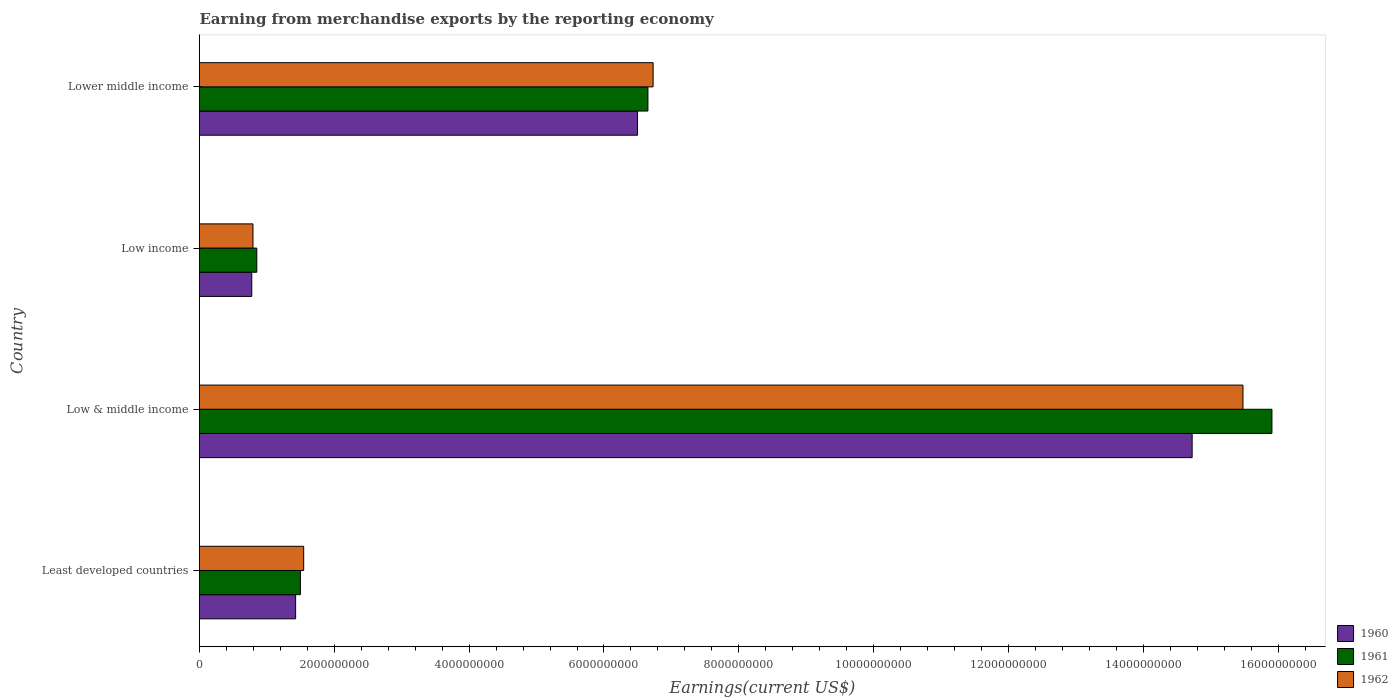How many different coloured bars are there?
Provide a short and direct response. 3. How many groups of bars are there?
Your response must be concise. 4. Are the number of bars on each tick of the Y-axis equal?
Provide a short and direct response. Yes. What is the amount earned from merchandise exports in 1962 in Low income?
Your response must be concise. 7.93e+08. Across all countries, what is the maximum amount earned from merchandise exports in 1961?
Ensure brevity in your answer.  1.59e+1. Across all countries, what is the minimum amount earned from merchandise exports in 1962?
Your answer should be compact. 7.93e+08. What is the total amount earned from merchandise exports in 1961 in the graph?
Your answer should be very brief. 2.49e+1. What is the difference between the amount earned from merchandise exports in 1961 in Least developed countries and that in Low & middle income?
Offer a very short reply. -1.44e+1. What is the difference between the amount earned from merchandise exports in 1962 in Lower middle income and the amount earned from merchandise exports in 1961 in Low & middle income?
Your answer should be very brief. -9.18e+09. What is the average amount earned from merchandise exports in 1962 per country?
Provide a short and direct response. 6.14e+09. What is the difference between the amount earned from merchandise exports in 1962 and amount earned from merchandise exports in 1960 in Low income?
Provide a short and direct response. 1.80e+07. What is the ratio of the amount earned from merchandise exports in 1960 in Low & middle income to that in Lower middle income?
Your answer should be compact. 2.27. Is the difference between the amount earned from merchandise exports in 1962 in Least developed countries and Lower middle income greater than the difference between the amount earned from merchandise exports in 1960 in Least developed countries and Lower middle income?
Your answer should be very brief. No. What is the difference between the highest and the second highest amount earned from merchandise exports in 1960?
Your answer should be very brief. 8.23e+09. What is the difference between the highest and the lowest amount earned from merchandise exports in 1962?
Offer a very short reply. 1.47e+1. Is the sum of the amount earned from merchandise exports in 1961 in Least developed countries and Low income greater than the maximum amount earned from merchandise exports in 1960 across all countries?
Make the answer very short. No. Is it the case that in every country, the sum of the amount earned from merchandise exports in 1961 and amount earned from merchandise exports in 1960 is greater than the amount earned from merchandise exports in 1962?
Offer a terse response. Yes. How many bars are there?
Give a very brief answer. 12. Are all the bars in the graph horizontal?
Offer a very short reply. Yes. How many countries are there in the graph?
Offer a terse response. 4. What is the difference between two consecutive major ticks on the X-axis?
Your response must be concise. 2.00e+09. Are the values on the major ticks of X-axis written in scientific E-notation?
Your answer should be compact. No. Does the graph contain any zero values?
Your answer should be very brief. No. Does the graph contain grids?
Make the answer very short. No. How many legend labels are there?
Keep it short and to the point. 3. What is the title of the graph?
Your answer should be very brief. Earning from merchandise exports by the reporting economy. Does "2002" appear as one of the legend labels in the graph?
Ensure brevity in your answer.  No. What is the label or title of the X-axis?
Your answer should be very brief. Earnings(current US$). What is the Earnings(current US$) of 1960 in Least developed countries?
Make the answer very short. 1.43e+09. What is the Earnings(current US$) in 1961 in Least developed countries?
Your answer should be very brief. 1.50e+09. What is the Earnings(current US$) of 1962 in Least developed countries?
Your answer should be very brief. 1.55e+09. What is the Earnings(current US$) in 1960 in Low & middle income?
Give a very brief answer. 1.47e+1. What is the Earnings(current US$) in 1961 in Low & middle income?
Keep it short and to the point. 1.59e+1. What is the Earnings(current US$) of 1962 in Low & middle income?
Your response must be concise. 1.55e+1. What is the Earnings(current US$) of 1960 in Low income?
Your response must be concise. 7.75e+08. What is the Earnings(current US$) of 1961 in Low income?
Ensure brevity in your answer.  8.50e+08. What is the Earnings(current US$) of 1962 in Low income?
Ensure brevity in your answer.  7.93e+08. What is the Earnings(current US$) of 1960 in Lower middle income?
Offer a terse response. 6.50e+09. What is the Earnings(current US$) in 1961 in Lower middle income?
Offer a terse response. 6.65e+09. What is the Earnings(current US$) in 1962 in Lower middle income?
Make the answer very short. 6.73e+09. Across all countries, what is the maximum Earnings(current US$) of 1960?
Provide a short and direct response. 1.47e+1. Across all countries, what is the maximum Earnings(current US$) in 1961?
Keep it short and to the point. 1.59e+1. Across all countries, what is the maximum Earnings(current US$) in 1962?
Your answer should be compact. 1.55e+1. Across all countries, what is the minimum Earnings(current US$) of 1960?
Ensure brevity in your answer.  7.75e+08. Across all countries, what is the minimum Earnings(current US$) of 1961?
Your answer should be very brief. 8.50e+08. Across all countries, what is the minimum Earnings(current US$) of 1962?
Offer a very short reply. 7.93e+08. What is the total Earnings(current US$) in 1960 in the graph?
Offer a very short reply. 2.34e+1. What is the total Earnings(current US$) of 1961 in the graph?
Provide a succinct answer. 2.49e+1. What is the total Earnings(current US$) of 1962 in the graph?
Offer a terse response. 2.45e+1. What is the difference between the Earnings(current US$) of 1960 in Least developed countries and that in Low & middle income?
Provide a succinct answer. -1.33e+1. What is the difference between the Earnings(current US$) of 1961 in Least developed countries and that in Low & middle income?
Offer a terse response. -1.44e+1. What is the difference between the Earnings(current US$) of 1962 in Least developed countries and that in Low & middle income?
Offer a very short reply. -1.39e+1. What is the difference between the Earnings(current US$) of 1960 in Least developed countries and that in Low income?
Provide a short and direct response. 6.51e+08. What is the difference between the Earnings(current US$) in 1961 in Least developed countries and that in Low income?
Provide a short and direct response. 6.47e+08. What is the difference between the Earnings(current US$) in 1962 in Least developed countries and that in Low income?
Offer a very short reply. 7.52e+08. What is the difference between the Earnings(current US$) in 1960 in Least developed countries and that in Lower middle income?
Give a very brief answer. -5.07e+09. What is the difference between the Earnings(current US$) of 1961 in Least developed countries and that in Lower middle income?
Give a very brief answer. -5.15e+09. What is the difference between the Earnings(current US$) in 1962 in Least developed countries and that in Lower middle income?
Offer a terse response. -5.18e+09. What is the difference between the Earnings(current US$) in 1960 in Low & middle income and that in Low income?
Your answer should be very brief. 1.39e+1. What is the difference between the Earnings(current US$) of 1961 in Low & middle income and that in Low income?
Your answer should be compact. 1.51e+1. What is the difference between the Earnings(current US$) in 1962 in Low & middle income and that in Low income?
Offer a very short reply. 1.47e+1. What is the difference between the Earnings(current US$) in 1960 in Low & middle income and that in Lower middle income?
Your answer should be compact. 8.23e+09. What is the difference between the Earnings(current US$) of 1961 in Low & middle income and that in Lower middle income?
Give a very brief answer. 9.26e+09. What is the difference between the Earnings(current US$) in 1962 in Low & middle income and that in Lower middle income?
Offer a very short reply. 8.75e+09. What is the difference between the Earnings(current US$) in 1960 in Low income and that in Lower middle income?
Ensure brevity in your answer.  -5.72e+09. What is the difference between the Earnings(current US$) of 1961 in Low income and that in Lower middle income?
Your answer should be compact. -5.80e+09. What is the difference between the Earnings(current US$) of 1962 in Low income and that in Lower middle income?
Provide a succinct answer. -5.94e+09. What is the difference between the Earnings(current US$) in 1960 in Least developed countries and the Earnings(current US$) in 1961 in Low & middle income?
Ensure brevity in your answer.  -1.45e+1. What is the difference between the Earnings(current US$) in 1960 in Least developed countries and the Earnings(current US$) in 1962 in Low & middle income?
Offer a very short reply. -1.41e+1. What is the difference between the Earnings(current US$) of 1961 in Least developed countries and the Earnings(current US$) of 1962 in Low & middle income?
Provide a succinct answer. -1.40e+1. What is the difference between the Earnings(current US$) of 1960 in Least developed countries and the Earnings(current US$) of 1961 in Low income?
Offer a terse response. 5.76e+08. What is the difference between the Earnings(current US$) in 1960 in Least developed countries and the Earnings(current US$) in 1962 in Low income?
Give a very brief answer. 6.33e+08. What is the difference between the Earnings(current US$) in 1961 in Least developed countries and the Earnings(current US$) in 1962 in Low income?
Your answer should be very brief. 7.04e+08. What is the difference between the Earnings(current US$) in 1960 in Least developed countries and the Earnings(current US$) in 1961 in Lower middle income?
Offer a very short reply. -5.23e+09. What is the difference between the Earnings(current US$) in 1960 in Least developed countries and the Earnings(current US$) in 1962 in Lower middle income?
Make the answer very short. -5.30e+09. What is the difference between the Earnings(current US$) of 1961 in Least developed countries and the Earnings(current US$) of 1962 in Lower middle income?
Offer a terse response. -5.23e+09. What is the difference between the Earnings(current US$) in 1960 in Low & middle income and the Earnings(current US$) in 1961 in Low income?
Ensure brevity in your answer.  1.39e+1. What is the difference between the Earnings(current US$) of 1960 in Low & middle income and the Earnings(current US$) of 1962 in Low income?
Give a very brief answer. 1.39e+1. What is the difference between the Earnings(current US$) in 1961 in Low & middle income and the Earnings(current US$) in 1962 in Low income?
Give a very brief answer. 1.51e+1. What is the difference between the Earnings(current US$) in 1960 in Low & middle income and the Earnings(current US$) in 1961 in Lower middle income?
Offer a very short reply. 8.07e+09. What is the difference between the Earnings(current US$) in 1960 in Low & middle income and the Earnings(current US$) in 1962 in Lower middle income?
Make the answer very short. 8.00e+09. What is the difference between the Earnings(current US$) in 1961 in Low & middle income and the Earnings(current US$) in 1962 in Lower middle income?
Ensure brevity in your answer.  9.18e+09. What is the difference between the Earnings(current US$) of 1960 in Low income and the Earnings(current US$) of 1961 in Lower middle income?
Give a very brief answer. -5.88e+09. What is the difference between the Earnings(current US$) in 1960 in Low income and the Earnings(current US$) in 1962 in Lower middle income?
Make the answer very short. -5.95e+09. What is the difference between the Earnings(current US$) of 1961 in Low income and the Earnings(current US$) of 1962 in Lower middle income?
Your answer should be very brief. -5.88e+09. What is the average Earnings(current US$) in 1960 per country?
Provide a short and direct response. 5.86e+09. What is the average Earnings(current US$) of 1961 per country?
Your response must be concise. 6.23e+09. What is the average Earnings(current US$) of 1962 per country?
Ensure brevity in your answer.  6.14e+09. What is the difference between the Earnings(current US$) in 1960 and Earnings(current US$) in 1961 in Least developed countries?
Give a very brief answer. -7.10e+07. What is the difference between the Earnings(current US$) of 1960 and Earnings(current US$) of 1962 in Least developed countries?
Keep it short and to the point. -1.20e+08. What is the difference between the Earnings(current US$) of 1961 and Earnings(current US$) of 1962 in Least developed countries?
Keep it short and to the point. -4.86e+07. What is the difference between the Earnings(current US$) in 1960 and Earnings(current US$) in 1961 in Low & middle income?
Keep it short and to the point. -1.18e+09. What is the difference between the Earnings(current US$) of 1960 and Earnings(current US$) of 1962 in Low & middle income?
Ensure brevity in your answer.  -7.54e+08. What is the difference between the Earnings(current US$) in 1961 and Earnings(current US$) in 1962 in Low & middle income?
Offer a terse response. 4.30e+08. What is the difference between the Earnings(current US$) of 1960 and Earnings(current US$) of 1961 in Low income?
Make the answer very short. -7.47e+07. What is the difference between the Earnings(current US$) of 1960 and Earnings(current US$) of 1962 in Low income?
Provide a succinct answer. -1.80e+07. What is the difference between the Earnings(current US$) in 1961 and Earnings(current US$) in 1962 in Low income?
Your response must be concise. 5.66e+07. What is the difference between the Earnings(current US$) in 1960 and Earnings(current US$) in 1961 in Lower middle income?
Make the answer very short. -1.54e+08. What is the difference between the Earnings(current US$) in 1960 and Earnings(current US$) in 1962 in Lower middle income?
Your response must be concise. -2.31e+08. What is the difference between the Earnings(current US$) of 1961 and Earnings(current US$) of 1962 in Lower middle income?
Make the answer very short. -7.70e+07. What is the ratio of the Earnings(current US$) in 1960 in Least developed countries to that in Low & middle income?
Provide a short and direct response. 0.1. What is the ratio of the Earnings(current US$) of 1961 in Least developed countries to that in Low & middle income?
Ensure brevity in your answer.  0.09. What is the ratio of the Earnings(current US$) in 1962 in Least developed countries to that in Low & middle income?
Your response must be concise. 0.1. What is the ratio of the Earnings(current US$) in 1960 in Least developed countries to that in Low income?
Ensure brevity in your answer.  1.84. What is the ratio of the Earnings(current US$) in 1961 in Least developed countries to that in Low income?
Your answer should be compact. 1.76. What is the ratio of the Earnings(current US$) of 1962 in Least developed countries to that in Low income?
Keep it short and to the point. 1.95. What is the ratio of the Earnings(current US$) of 1960 in Least developed countries to that in Lower middle income?
Your response must be concise. 0.22. What is the ratio of the Earnings(current US$) in 1961 in Least developed countries to that in Lower middle income?
Offer a very short reply. 0.23. What is the ratio of the Earnings(current US$) in 1962 in Least developed countries to that in Lower middle income?
Your answer should be very brief. 0.23. What is the ratio of the Earnings(current US$) in 1960 in Low & middle income to that in Low income?
Your answer should be very brief. 19. What is the ratio of the Earnings(current US$) of 1961 in Low & middle income to that in Low income?
Provide a succinct answer. 18.72. What is the ratio of the Earnings(current US$) of 1962 in Low & middle income to that in Low income?
Keep it short and to the point. 19.51. What is the ratio of the Earnings(current US$) of 1960 in Low & middle income to that in Lower middle income?
Provide a succinct answer. 2.27. What is the ratio of the Earnings(current US$) in 1961 in Low & middle income to that in Lower middle income?
Offer a very short reply. 2.39. What is the ratio of the Earnings(current US$) in 1962 in Low & middle income to that in Lower middle income?
Your answer should be compact. 2.3. What is the ratio of the Earnings(current US$) of 1960 in Low income to that in Lower middle income?
Give a very brief answer. 0.12. What is the ratio of the Earnings(current US$) of 1961 in Low income to that in Lower middle income?
Offer a terse response. 0.13. What is the ratio of the Earnings(current US$) in 1962 in Low income to that in Lower middle income?
Give a very brief answer. 0.12. What is the difference between the highest and the second highest Earnings(current US$) in 1960?
Your response must be concise. 8.23e+09. What is the difference between the highest and the second highest Earnings(current US$) of 1961?
Make the answer very short. 9.26e+09. What is the difference between the highest and the second highest Earnings(current US$) of 1962?
Offer a terse response. 8.75e+09. What is the difference between the highest and the lowest Earnings(current US$) in 1960?
Provide a short and direct response. 1.39e+1. What is the difference between the highest and the lowest Earnings(current US$) in 1961?
Provide a short and direct response. 1.51e+1. What is the difference between the highest and the lowest Earnings(current US$) of 1962?
Your response must be concise. 1.47e+1. 